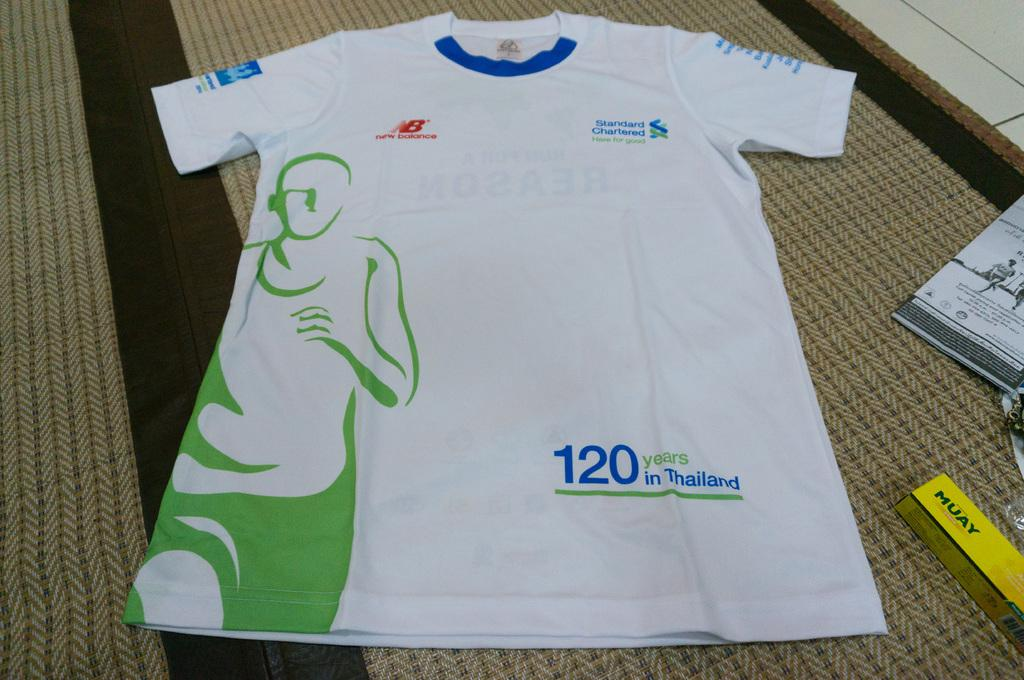<image>
Render a clear and concise summary of the photo. A white jersey that says 120 years in Thailand. 